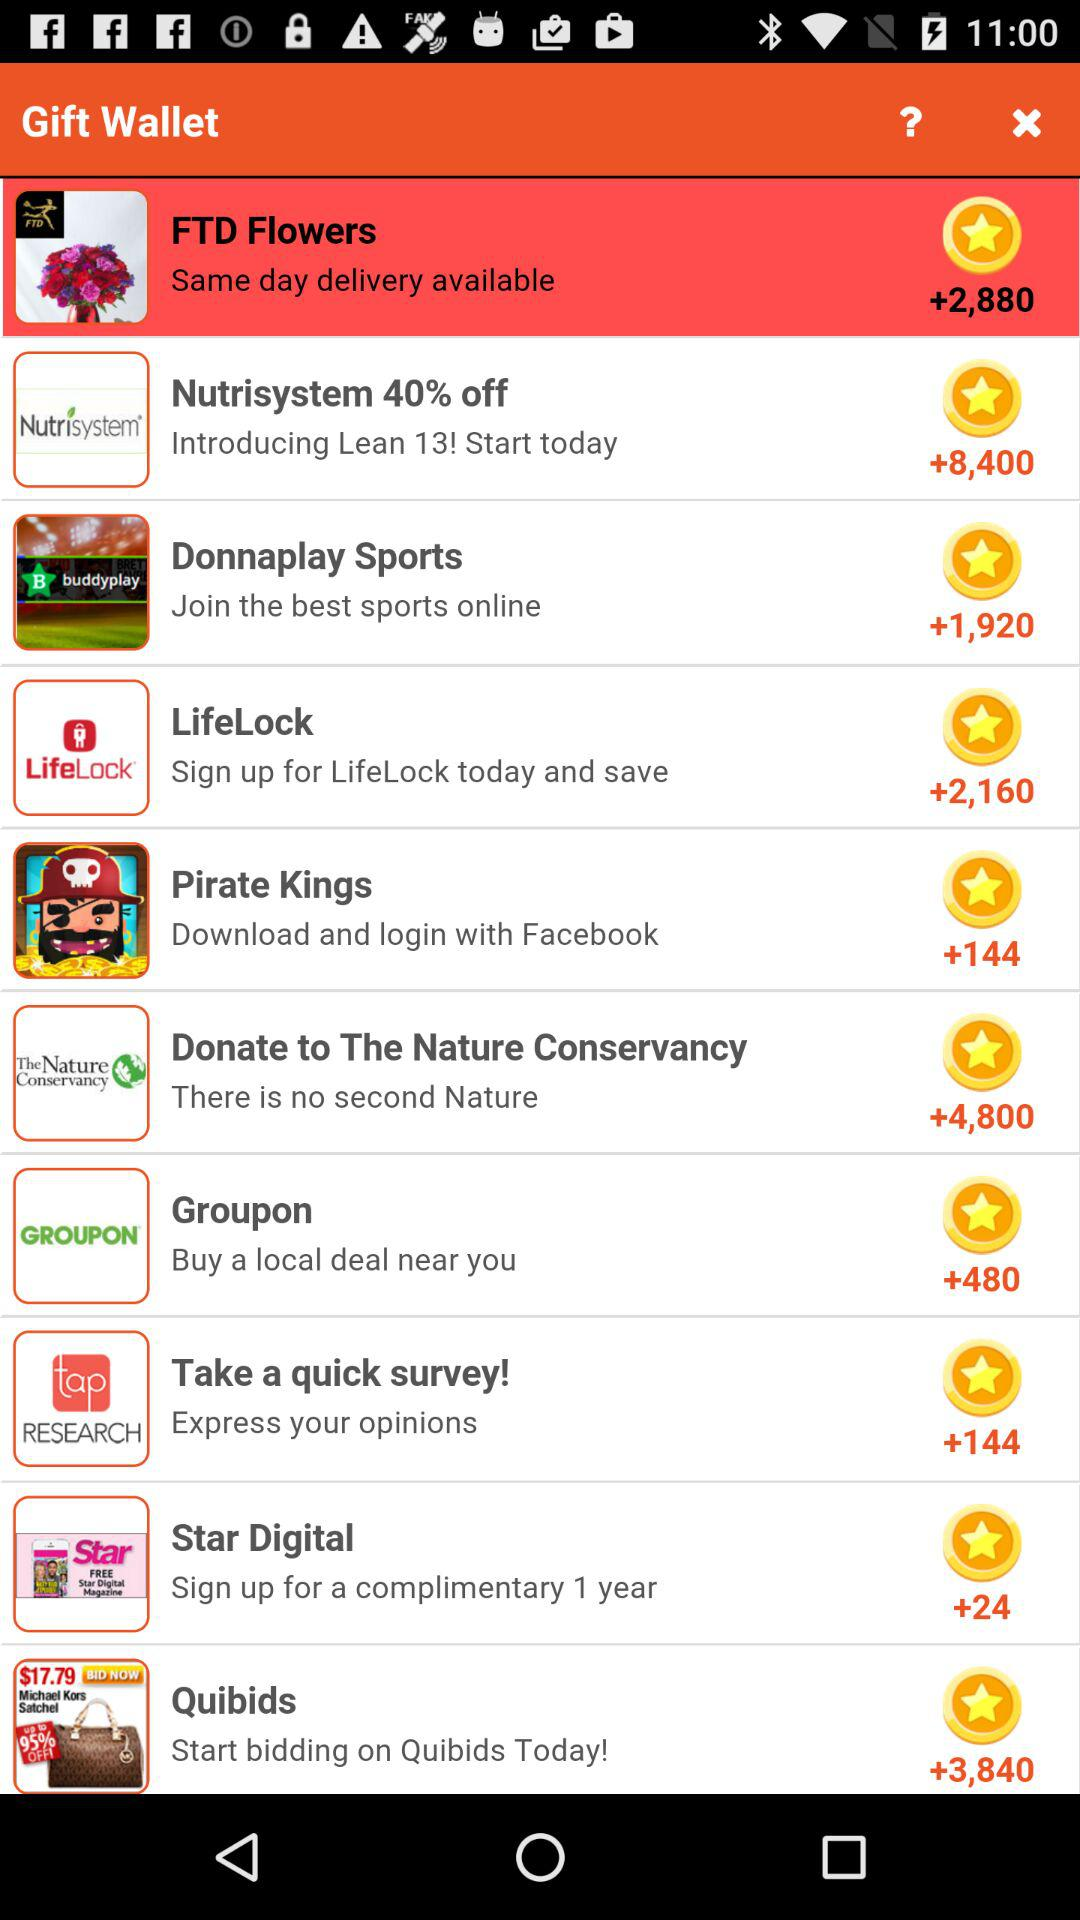By which app can we download and login pirates king?
When the provided information is insufficient, respond with <no answer>. <no answer> 